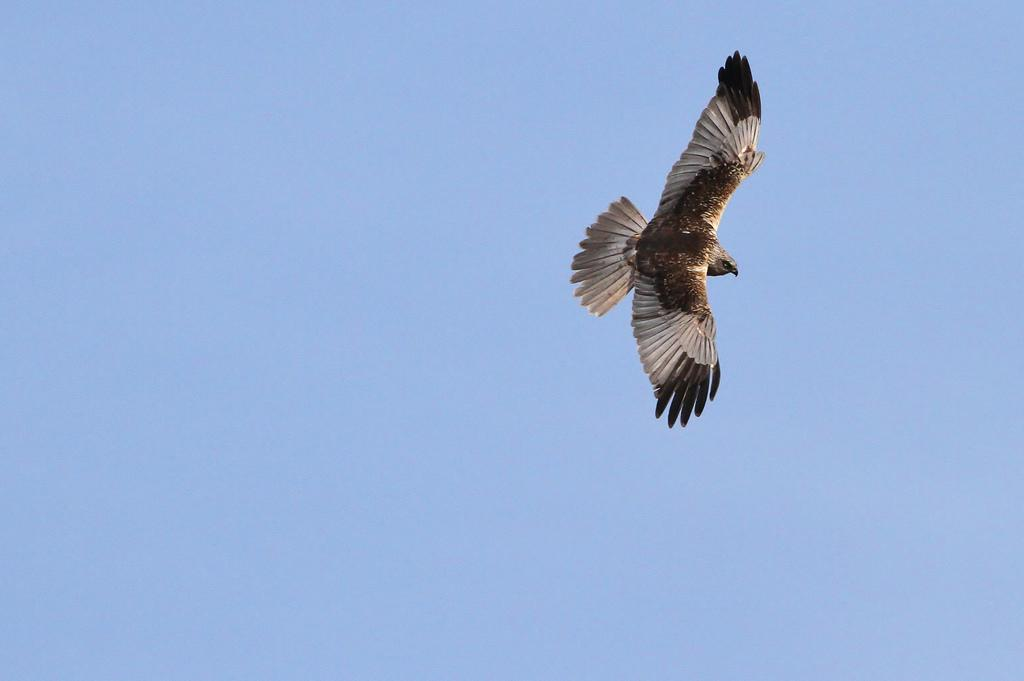What type of animal can be seen in the image? There is a bird in the image. What is the bird doing in the image? The bird is flying in the air. What can be seen in the background of the image? The sky is visible in the background of the image. How does the bird taste the water while swimming in the image? The bird is not swimming in the image; it is flying. Additionally, birds do not taste water by swimming. 